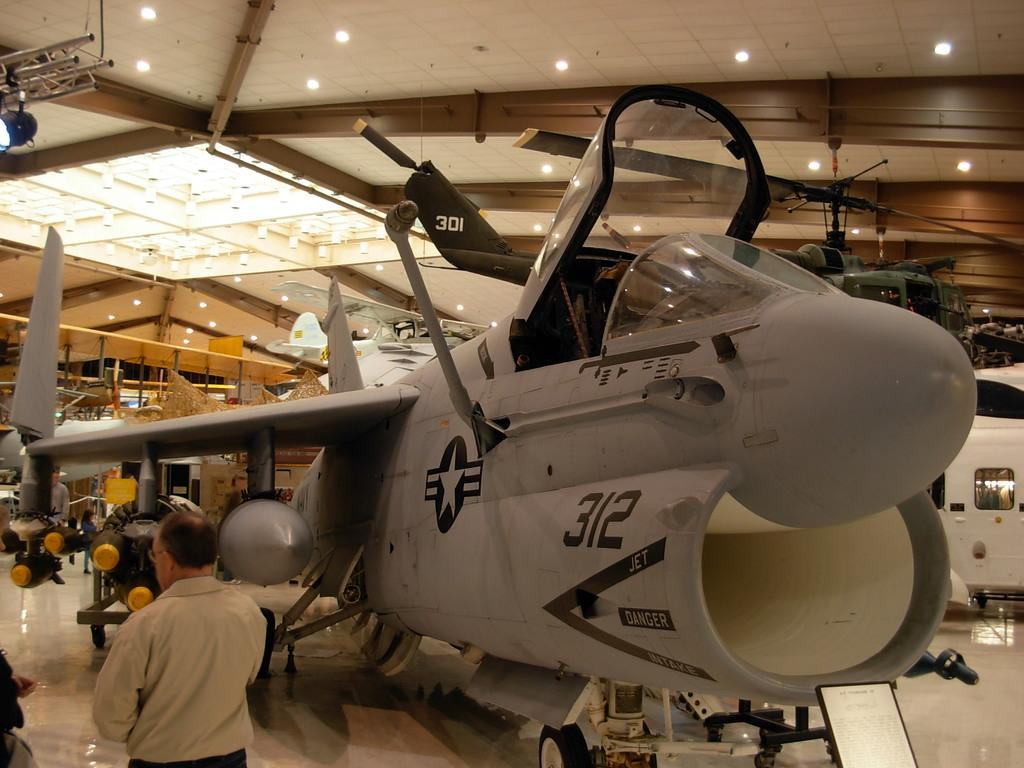What is the main subject in the image? There is a flying jet in the image. What else can be seen in the image besides the jet? There are people standing in the image, and they are wearing clothes. What is the surface on which the people are standing? There is a floor visible in the image. Are there any other elements in the image that provide illumination? Yes, there are lights in the image. What type of stick is being used by the people in the image? There is no stick present in the image; the people are simply standing. What kind of tail can be seen on the jet in the image? The jet in the image does not have a visible tail. 